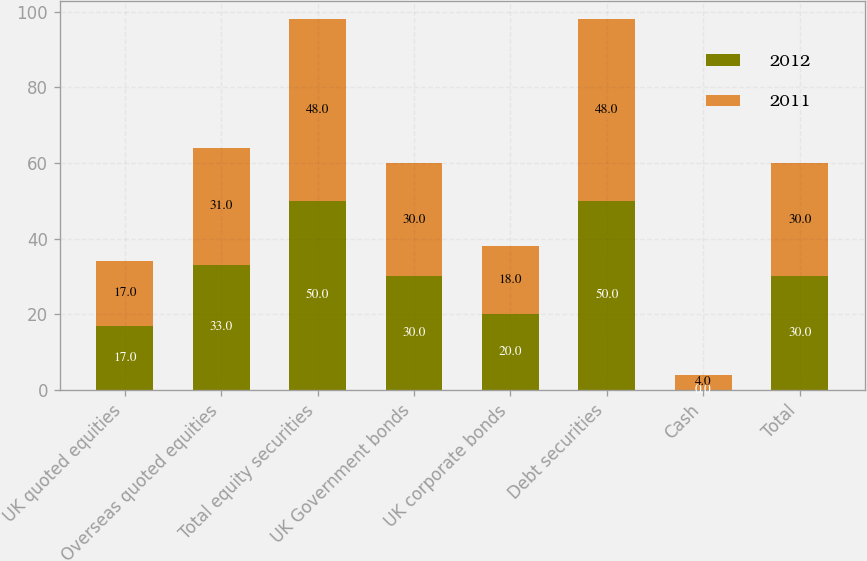<chart> <loc_0><loc_0><loc_500><loc_500><stacked_bar_chart><ecel><fcel>UK quoted equities<fcel>Overseas quoted equities<fcel>Total equity securities<fcel>UK Government bonds<fcel>UK corporate bonds<fcel>Debt securities<fcel>Cash<fcel>Total<nl><fcel>2012<fcel>17<fcel>33<fcel>50<fcel>30<fcel>20<fcel>50<fcel>0<fcel>30<nl><fcel>2011<fcel>17<fcel>31<fcel>48<fcel>30<fcel>18<fcel>48<fcel>4<fcel>30<nl></chart> 